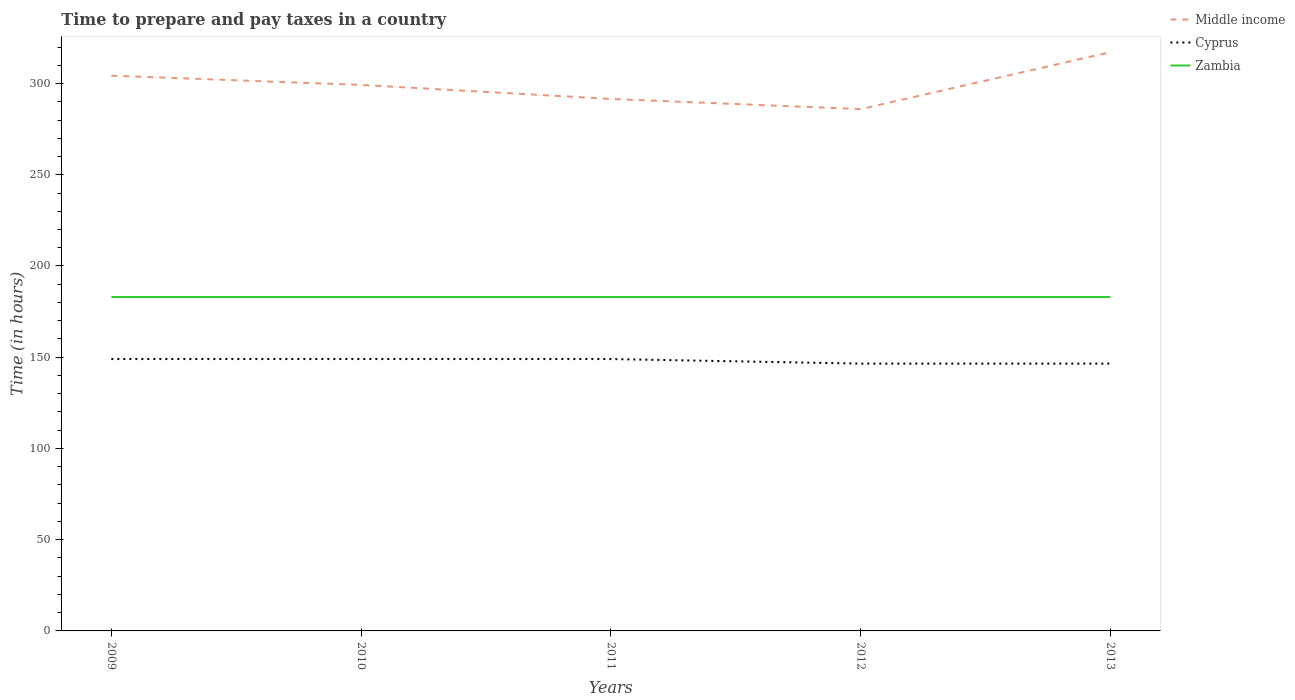How many different coloured lines are there?
Give a very brief answer. 3. Is the number of lines equal to the number of legend labels?
Your answer should be compact. Yes. Across all years, what is the maximum number of hours required to prepare and pay taxes in Middle income?
Keep it short and to the point. 285.97. In which year was the number of hours required to prepare and pay taxes in Middle income maximum?
Your answer should be compact. 2012. What is the difference between the highest and the second highest number of hours required to prepare and pay taxes in Zambia?
Provide a short and direct response. 0. Is the number of hours required to prepare and pay taxes in Middle income strictly greater than the number of hours required to prepare and pay taxes in Cyprus over the years?
Your answer should be compact. No. How many lines are there?
Make the answer very short. 3. What is the difference between two consecutive major ticks on the Y-axis?
Offer a very short reply. 50. Where does the legend appear in the graph?
Ensure brevity in your answer.  Top right. What is the title of the graph?
Offer a terse response. Time to prepare and pay taxes in a country. What is the label or title of the Y-axis?
Make the answer very short. Time (in hours). What is the Time (in hours) in Middle income in 2009?
Offer a very short reply. 304.31. What is the Time (in hours) of Cyprus in 2009?
Ensure brevity in your answer.  149. What is the Time (in hours) in Zambia in 2009?
Ensure brevity in your answer.  183. What is the Time (in hours) of Middle income in 2010?
Offer a very short reply. 299.24. What is the Time (in hours) in Cyprus in 2010?
Your answer should be compact. 149. What is the Time (in hours) of Zambia in 2010?
Your answer should be compact. 183. What is the Time (in hours) in Middle income in 2011?
Your answer should be compact. 291.56. What is the Time (in hours) in Cyprus in 2011?
Provide a short and direct response. 149. What is the Time (in hours) in Zambia in 2011?
Your answer should be compact. 183. What is the Time (in hours) in Middle income in 2012?
Offer a terse response. 285.97. What is the Time (in hours) of Cyprus in 2012?
Offer a terse response. 146.5. What is the Time (in hours) of Zambia in 2012?
Keep it short and to the point. 183. What is the Time (in hours) in Middle income in 2013?
Your answer should be compact. 317.19. What is the Time (in hours) in Cyprus in 2013?
Your response must be concise. 146.5. What is the Time (in hours) of Zambia in 2013?
Give a very brief answer. 183. Across all years, what is the maximum Time (in hours) in Middle income?
Offer a very short reply. 317.19. Across all years, what is the maximum Time (in hours) in Cyprus?
Give a very brief answer. 149. Across all years, what is the maximum Time (in hours) of Zambia?
Make the answer very short. 183. Across all years, what is the minimum Time (in hours) of Middle income?
Offer a terse response. 285.97. Across all years, what is the minimum Time (in hours) in Cyprus?
Provide a succinct answer. 146.5. Across all years, what is the minimum Time (in hours) of Zambia?
Provide a succinct answer. 183. What is the total Time (in hours) of Middle income in the graph?
Make the answer very short. 1498.26. What is the total Time (in hours) of Cyprus in the graph?
Provide a succinct answer. 740. What is the total Time (in hours) of Zambia in the graph?
Make the answer very short. 915. What is the difference between the Time (in hours) of Middle income in 2009 and that in 2010?
Provide a succinct answer. 5.07. What is the difference between the Time (in hours) in Zambia in 2009 and that in 2010?
Make the answer very short. 0. What is the difference between the Time (in hours) of Middle income in 2009 and that in 2011?
Your response must be concise. 12.75. What is the difference between the Time (in hours) of Cyprus in 2009 and that in 2011?
Make the answer very short. 0. What is the difference between the Time (in hours) in Zambia in 2009 and that in 2011?
Provide a short and direct response. 0. What is the difference between the Time (in hours) of Middle income in 2009 and that in 2012?
Your answer should be compact. 18.33. What is the difference between the Time (in hours) of Middle income in 2009 and that in 2013?
Ensure brevity in your answer.  -12.89. What is the difference between the Time (in hours) in Cyprus in 2009 and that in 2013?
Offer a terse response. 2.5. What is the difference between the Time (in hours) of Zambia in 2009 and that in 2013?
Provide a short and direct response. 0. What is the difference between the Time (in hours) in Middle income in 2010 and that in 2011?
Offer a very short reply. 7.68. What is the difference between the Time (in hours) of Cyprus in 2010 and that in 2011?
Ensure brevity in your answer.  0. What is the difference between the Time (in hours) of Middle income in 2010 and that in 2012?
Your response must be concise. 13.26. What is the difference between the Time (in hours) in Middle income in 2010 and that in 2013?
Your response must be concise. -17.96. What is the difference between the Time (in hours) in Zambia in 2010 and that in 2013?
Your answer should be very brief. 0. What is the difference between the Time (in hours) of Middle income in 2011 and that in 2012?
Ensure brevity in your answer.  5.58. What is the difference between the Time (in hours) in Zambia in 2011 and that in 2012?
Keep it short and to the point. 0. What is the difference between the Time (in hours) in Middle income in 2011 and that in 2013?
Offer a terse response. -25.64. What is the difference between the Time (in hours) in Middle income in 2012 and that in 2013?
Provide a short and direct response. -31.22. What is the difference between the Time (in hours) of Cyprus in 2012 and that in 2013?
Make the answer very short. 0. What is the difference between the Time (in hours) in Zambia in 2012 and that in 2013?
Keep it short and to the point. 0. What is the difference between the Time (in hours) in Middle income in 2009 and the Time (in hours) in Cyprus in 2010?
Make the answer very short. 155.31. What is the difference between the Time (in hours) of Middle income in 2009 and the Time (in hours) of Zambia in 2010?
Provide a succinct answer. 121.31. What is the difference between the Time (in hours) in Cyprus in 2009 and the Time (in hours) in Zambia in 2010?
Provide a succinct answer. -34. What is the difference between the Time (in hours) of Middle income in 2009 and the Time (in hours) of Cyprus in 2011?
Your answer should be compact. 155.31. What is the difference between the Time (in hours) in Middle income in 2009 and the Time (in hours) in Zambia in 2011?
Your answer should be compact. 121.31. What is the difference between the Time (in hours) in Cyprus in 2009 and the Time (in hours) in Zambia in 2011?
Ensure brevity in your answer.  -34. What is the difference between the Time (in hours) of Middle income in 2009 and the Time (in hours) of Cyprus in 2012?
Ensure brevity in your answer.  157.81. What is the difference between the Time (in hours) of Middle income in 2009 and the Time (in hours) of Zambia in 2012?
Your answer should be compact. 121.31. What is the difference between the Time (in hours) of Cyprus in 2009 and the Time (in hours) of Zambia in 2012?
Offer a very short reply. -34. What is the difference between the Time (in hours) of Middle income in 2009 and the Time (in hours) of Cyprus in 2013?
Your answer should be very brief. 157.81. What is the difference between the Time (in hours) in Middle income in 2009 and the Time (in hours) in Zambia in 2013?
Provide a short and direct response. 121.31. What is the difference between the Time (in hours) of Cyprus in 2009 and the Time (in hours) of Zambia in 2013?
Offer a terse response. -34. What is the difference between the Time (in hours) in Middle income in 2010 and the Time (in hours) in Cyprus in 2011?
Offer a terse response. 150.24. What is the difference between the Time (in hours) in Middle income in 2010 and the Time (in hours) in Zambia in 2011?
Keep it short and to the point. 116.24. What is the difference between the Time (in hours) of Cyprus in 2010 and the Time (in hours) of Zambia in 2011?
Your answer should be very brief. -34. What is the difference between the Time (in hours) in Middle income in 2010 and the Time (in hours) in Cyprus in 2012?
Your answer should be very brief. 152.74. What is the difference between the Time (in hours) in Middle income in 2010 and the Time (in hours) in Zambia in 2012?
Your answer should be very brief. 116.24. What is the difference between the Time (in hours) in Cyprus in 2010 and the Time (in hours) in Zambia in 2012?
Provide a short and direct response. -34. What is the difference between the Time (in hours) of Middle income in 2010 and the Time (in hours) of Cyprus in 2013?
Your response must be concise. 152.74. What is the difference between the Time (in hours) in Middle income in 2010 and the Time (in hours) in Zambia in 2013?
Keep it short and to the point. 116.24. What is the difference between the Time (in hours) of Cyprus in 2010 and the Time (in hours) of Zambia in 2013?
Your answer should be compact. -34. What is the difference between the Time (in hours) of Middle income in 2011 and the Time (in hours) of Cyprus in 2012?
Make the answer very short. 145.06. What is the difference between the Time (in hours) of Middle income in 2011 and the Time (in hours) of Zambia in 2012?
Make the answer very short. 108.56. What is the difference between the Time (in hours) in Cyprus in 2011 and the Time (in hours) in Zambia in 2012?
Offer a terse response. -34. What is the difference between the Time (in hours) in Middle income in 2011 and the Time (in hours) in Cyprus in 2013?
Offer a very short reply. 145.06. What is the difference between the Time (in hours) in Middle income in 2011 and the Time (in hours) in Zambia in 2013?
Your answer should be compact. 108.56. What is the difference between the Time (in hours) of Cyprus in 2011 and the Time (in hours) of Zambia in 2013?
Give a very brief answer. -34. What is the difference between the Time (in hours) in Middle income in 2012 and the Time (in hours) in Cyprus in 2013?
Your answer should be very brief. 139.47. What is the difference between the Time (in hours) of Middle income in 2012 and the Time (in hours) of Zambia in 2013?
Ensure brevity in your answer.  102.97. What is the difference between the Time (in hours) in Cyprus in 2012 and the Time (in hours) in Zambia in 2013?
Your answer should be very brief. -36.5. What is the average Time (in hours) in Middle income per year?
Keep it short and to the point. 299.65. What is the average Time (in hours) of Cyprus per year?
Make the answer very short. 148. What is the average Time (in hours) in Zambia per year?
Keep it short and to the point. 183. In the year 2009, what is the difference between the Time (in hours) of Middle income and Time (in hours) of Cyprus?
Offer a very short reply. 155.31. In the year 2009, what is the difference between the Time (in hours) in Middle income and Time (in hours) in Zambia?
Keep it short and to the point. 121.31. In the year 2009, what is the difference between the Time (in hours) in Cyprus and Time (in hours) in Zambia?
Offer a terse response. -34. In the year 2010, what is the difference between the Time (in hours) in Middle income and Time (in hours) in Cyprus?
Give a very brief answer. 150.24. In the year 2010, what is the difference between the Time (in hours) in Middle income and Time (in hours) in Zambia?
Your answer should be compact. 116.24. In the year 2010, what is the difference between the Time (in hours) of Cyprus and Time (in hours) of Zambia?
Give a very brief answer. -34. In the year 2011, what is the difference between the Time (in hours) in Middle income and Time (in hours) in Cyprus?
Your response must be concise. 142.56. In the year 2011, what is the difference between the Time (in hours) of Middle income and Time (in hours) of Zambia?
Keep it short and to the point. 108.56. In the year 2011, what is the difference between the Time (in hours) in Cyprus and Time (in hours) in Zambia?
Your answer should be compact. -34. In the year 2012, what is the difference between the Time (in hours) of Middle income and Time (in hours) of Cyprus?
Ensure brevity in your answer.  139.47. In the year 2012, what is the difference between the Time (in hours) in Middle income and Time (in hours) in Zambia?
Keep it short and to the point. 102.97. In the year 2012, what is the difference between the Time (in hours) in Cyprus and Time (in hours) in Zambia?
Your response must be concise. -36.5. In the year 2013, what is the difference between the Time (in hours) of Middle income and Time (in hours) of Cyprus?
Provide a succinct answer. 170.69. In the year 2013, what is the difference between the Time (in hours) in Middle income and Time (in hours) in Zambia?
Your answer should be very brief. 134.19. In the year 2013, what is the difference between the Time (in hours) in Cyprus and Time (in hours) in Zambia?
Give a very brief answer. -36.5. What is the ratio of the Time (in hours) of Middle income in 2009 to that in 2010?
Make the answer very short. 1.02. What is the ratio of the Time (in hours) in Cyprus in 2009 to that in 2010?
Your answer should be very brief. 1. What is the ratio of the Time (in hours) in Middle income in 2009 to that in 2011?
Keep it short and to the point. 1.04. What is the ratio of the Time (in hours) of Zambia in 2009 to that in 2011?
Offer a very short reply. 1. What is the ratio of the Time (in hours) of Middle income in 2009 to that in 2012?
Make the answer very short. 1.06. What is the ratio of the Time (in hours) in Cyprus in 2009 to that in 2012?
Provide a succinct answer. 1.02. What is the ratio of the Time (in hours) of Zambia in 2009 to that in 2012?
Offer a terse response. 1. What is the ratio of the Time (in hours) in Middle income in 2009 to that in 2013?
Provide a succinct answer. 0.96. What is the ratio of the Time (in hours) in Cyprus in 2009 to that in 2013?
Your answer should be compact. 1.02. What is the ratio of the Time (in hours) of Middle income in 2010 to that in 2011?
Provide a short and direct response. 1.03. What is the ratio of the Time (in hours) of Cyprus in 2010 to that in 2011?
Your answer should be very brief. 1. What is the ratio of the Time (in hours) of Middle income in 2010 to that in 2012?
Offer a very short reply. 1.05. What is the ratio of the Time (in hours) in Cyprus in 2010 to that in 2012?
Your answer should be compact. 1.02. What is the ratio of the Time (in hours) in Middle income in 2010 to that in 2013?
Your response must be concise. 0.94. What is the ratio of the Time (in hours) of Cyprus in 2010 to that in 2013?
Make the answer very short. 1.02. What is the ratio of the Time (in hours) of Zambia in 2010 to that in 2013?
Your response must be concise. 1. What is the ratio of the Time (in hours) in Middle income in 2011 to that in 2012?
Provide a short and direct response. 1.02. What is the ratio of the Time (in hours) of Cyprus in 2011 to that in 2012?
Your answer should be very brief. 1.02. What is the ratio of the Time (in hours) of Middle income in 2011 to that in 2013?
Your response must be concise. 0.92. What is the ratio of the Time (in hours) in Cyprus in 2011 to that in 2013?
Provide a short and direct response. 1.02. What is the ratio of the Time (in hours) of Middle income in 2012 to that in 2013?
Make the answer very short. 0.9. What is the ratio of the Time (in hours) of Cyprus in 2012 to that in 2013?
Your response must be concise. 1. What is the difference between the highest and the second highest Time (in hours) of Middle income?
Your response must be concise. 12.89. What is the difference between the highest and the second highest Time (in hours) in Cyprus?
Make the answer very short. 0. What is the difference between the highest and the second highest Time (in hours) in Zambia?
Your response must be concise. 0. What is the difference between the highest and the lowest Time (in hours) of Middle income?
Your answer should be very brief. 31.22. What is the difference between the highest and the lowest Time (in hours) of Zambia?
Your response must be concise. 0. 